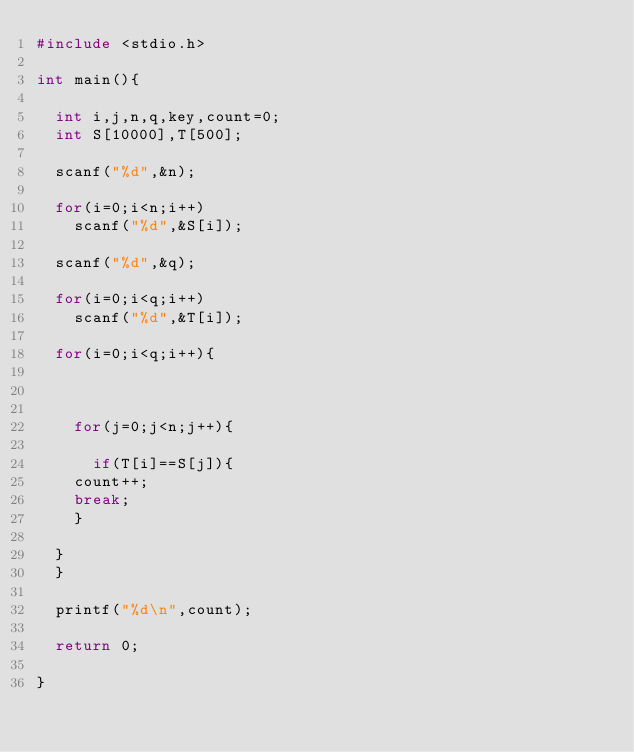Convert code to text. <code><loc_0><loc_0><loc_500><loc_500><_C++_>#include <stdio.h>

int main(){

  int i,j,n,q,key,count=0;
  int S[10000],T[500];

  scanf("%d",&n);

  for(i=0;i<n;i++)
    scanf("%d",&S[i]);

  scanf("%d",&q);

  for(i=0;i<q;i++)
    scanf("%d",&T[i]);

  for(i=0;i<q;i++){

    

    for(j=0;j<n;j++){

      if(T[i]==S[j]){
	count++;
	break;
    }

  }
  }

  printf("%d\n",count);

  return 0;

}</code> 